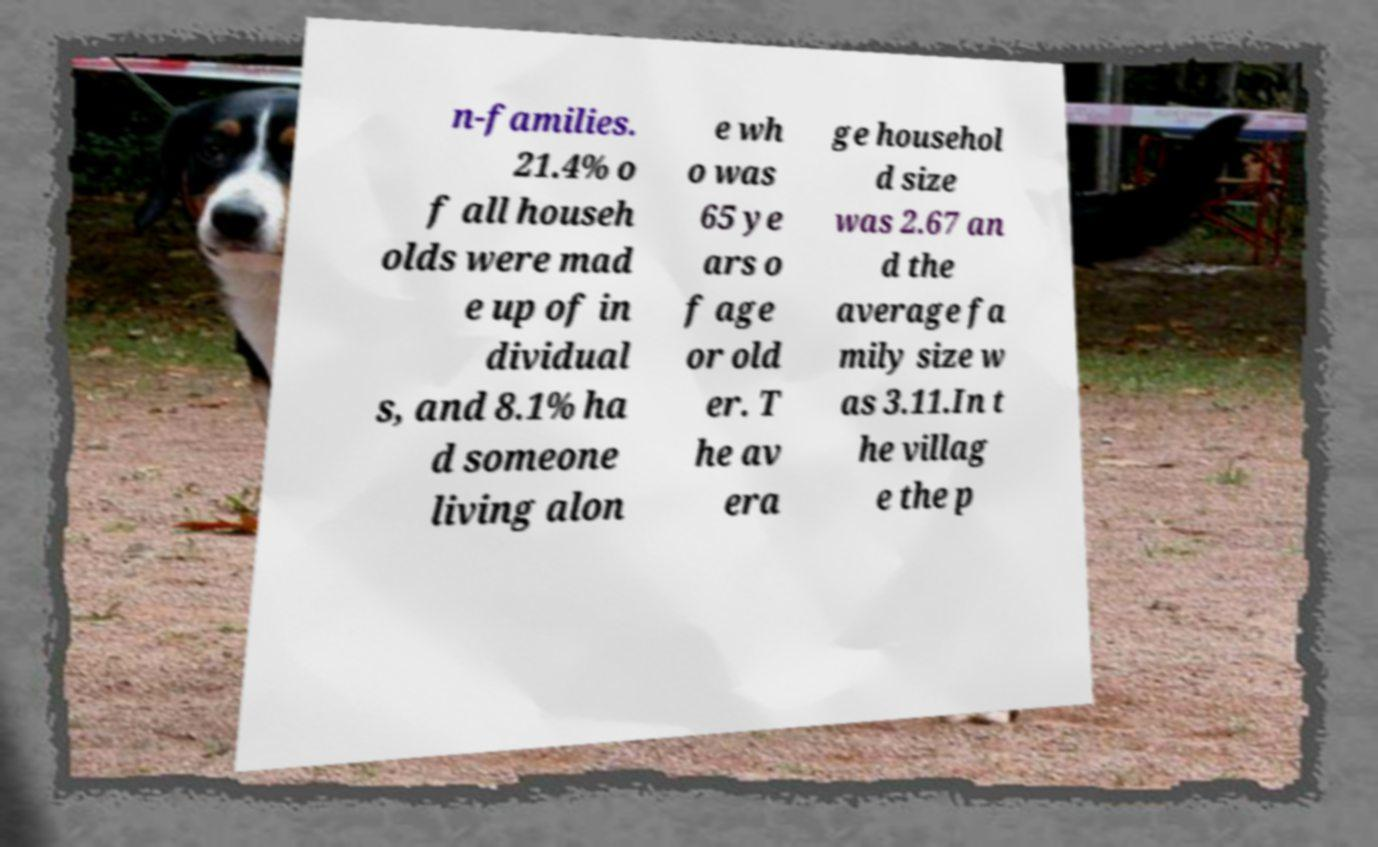Can you read and provide the text displayed in the image?This photo seems to have some interesting text. Can you extract and type it out for me? n-families. 21.4% o f all househ olds were mad e up of in dividual s, and 8.1% ha d someone living alon e wh o was 65 ye ars o f age or old er. T he av era ge househol d size was 2.67 an d the average fa mily size w as 3.11.In t he villag e the p 